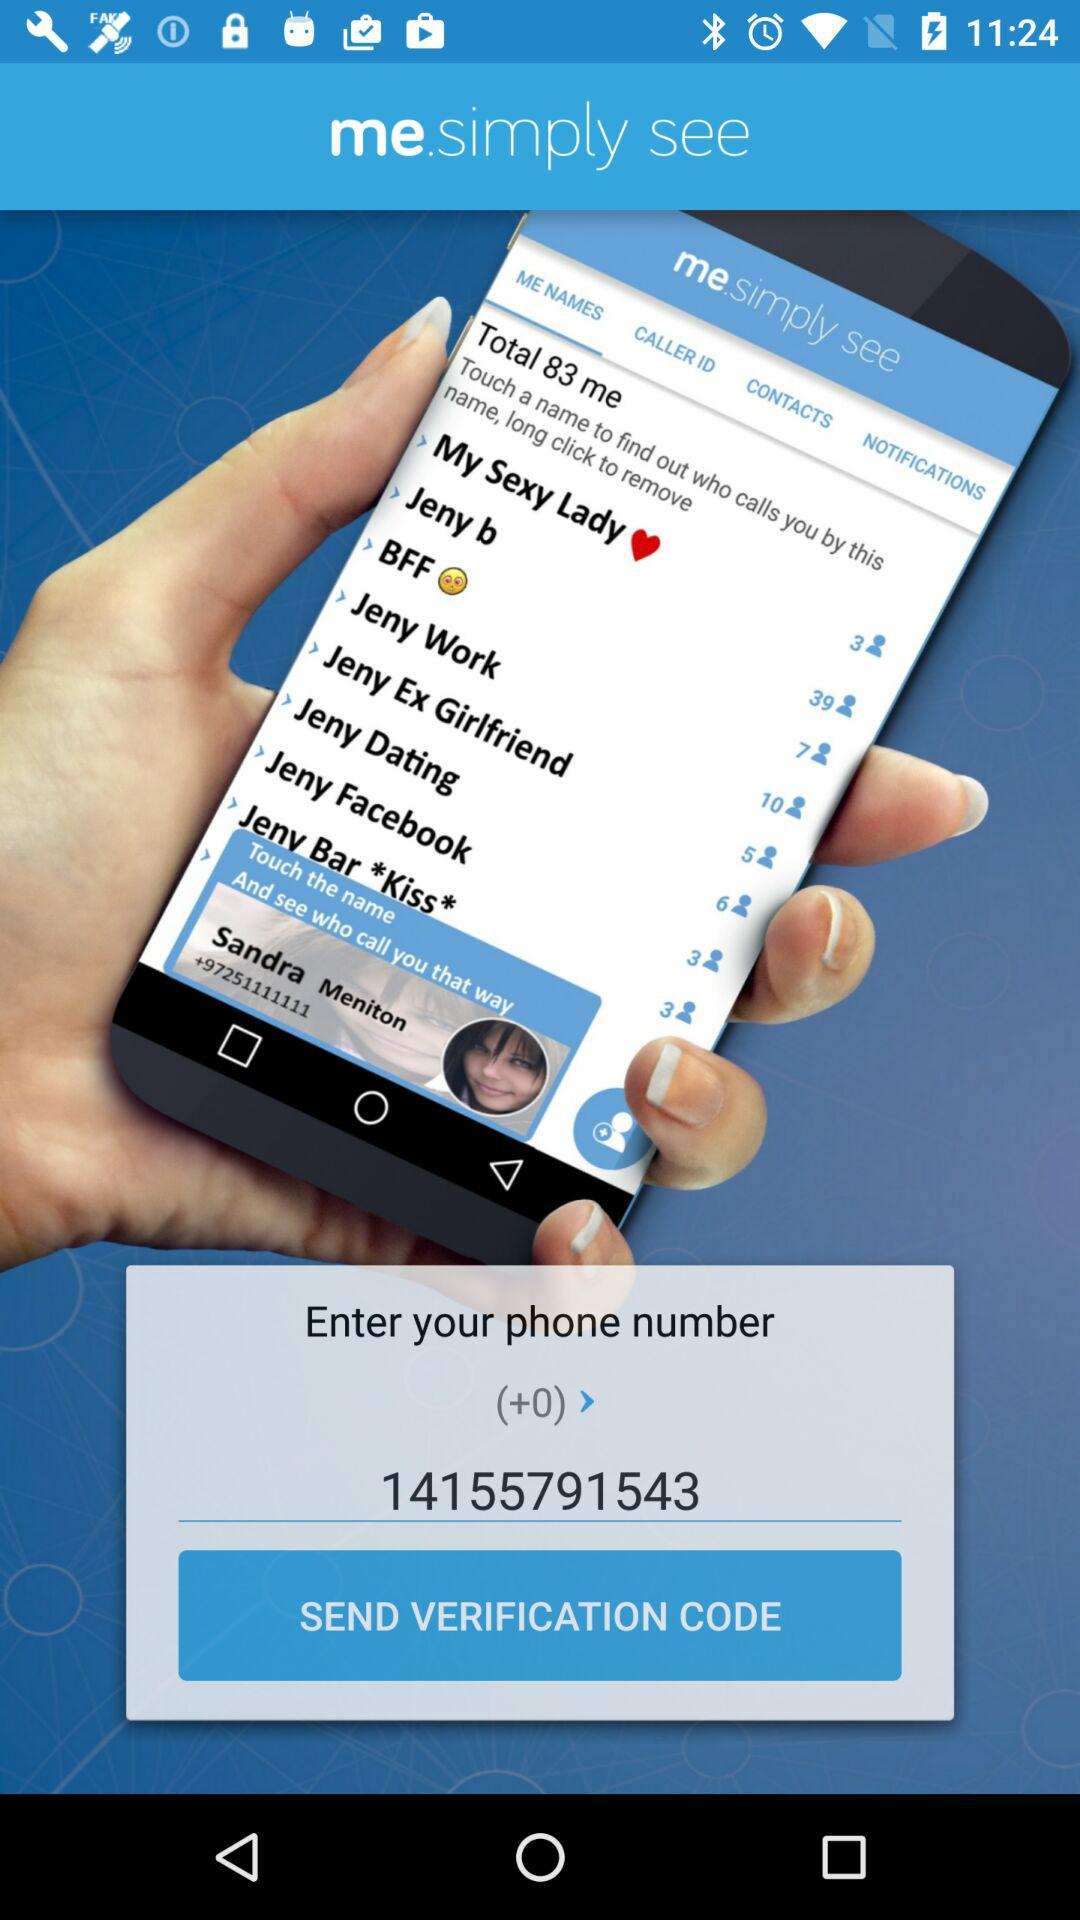What is the name of the application? The name of the application is "me.simply see". 